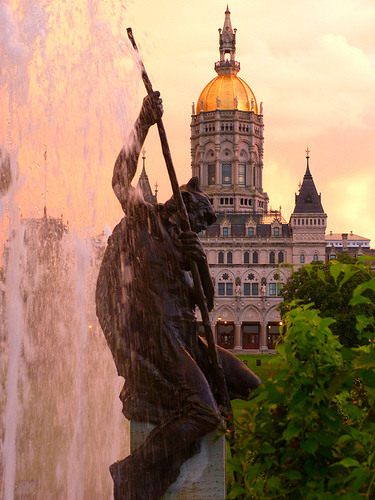<image>
Can you confirm if the statue is in front of the building? Yes. The statue is positioned in front of the building, appearing closer to the camera viewpoint. 